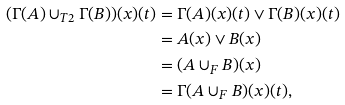Convert formula to latex. <formula><loc_0><loc_0><loc_500><loc_500>( \Gamma ( A ) \cup _ { T 2 } \Gamma ( B ) ) ( x ) ( t ) & = \Gamma ( A ) ( x ) ( t ) \vee \Gamma ( B ) ( x ) ( t ) \\ & = A ( x ) \vee B ( x ) \\ & = ( A \cup _ { F } B ) ( x ) \\ & = \Gamma ( A \cup _ { F } B ) ( x ) ( t ) ,</formula> 